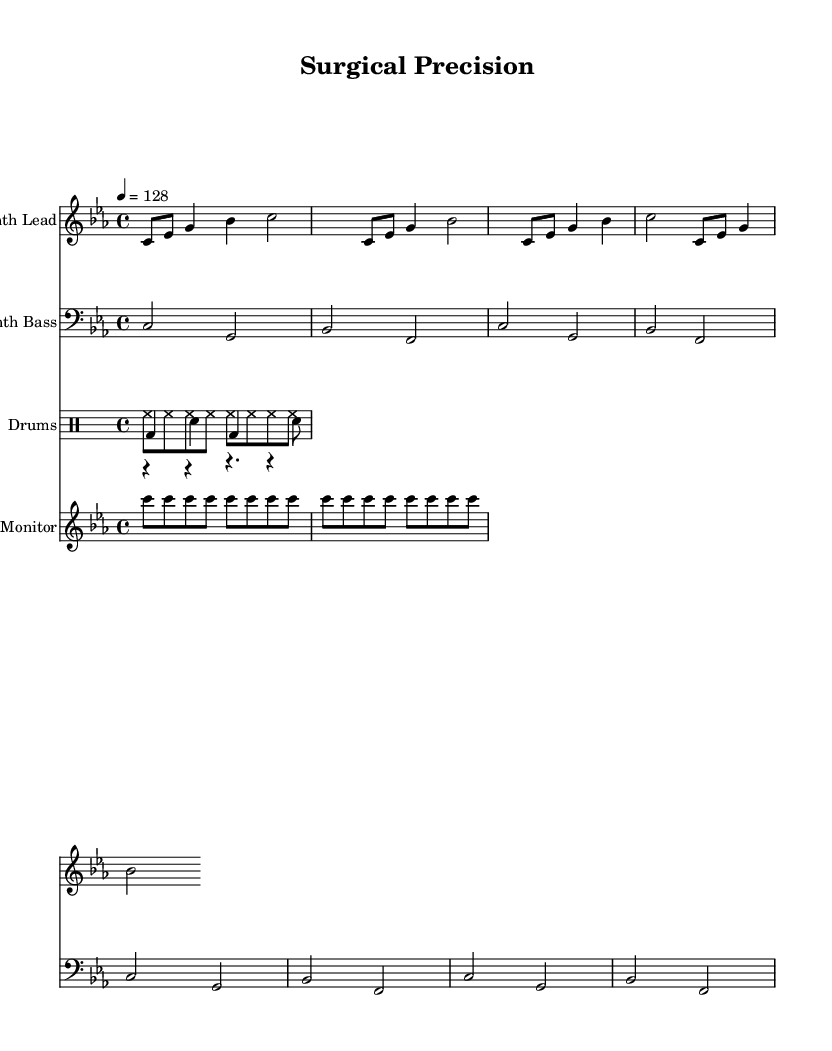What is the key signature of this music? The key signature is C minor, which indicates that it has three flats (B-flat, E-flat, and A-flat). This is determined by checking the key signature at the beginning of the staff where the notes are written.
Answer: C minor What is the time signature of this music? The time signature is 4/4, which means there are four beats in a measure and the quarter note gets one beat. This is indicated explicitly at the start of the score after the key signature.
Answer: 4/4 What is the tempo marking of this music? The tempo marking is 128 beats per minute, which sets the speed of the piece. This is specified as "4 = 128" at the start of the score, indicating that the quarter note is equal to 128 beats per minute.
Answer: 128 How many repetitions does the synth bass pattern have? The synth bass pattern is repeated four times, as indicated by the "repeat unfold 4" notation in the code. This means that the entire bass pattern is played four times in sequence.
Answer: 4 Which instrument plays the heart monitor pattern? The heart monitor pattern is played by a dedicated staff labeled "Heart Monitor" in the score. This indicates that this particular pattern is associated with a specific instrumental voice in the arrangement.
Answer: Heart Monitor How is the drum pattern structured in terms of beats? The drum patterns consist of kick, snare, and hi-hat each with specific rhythmic figures. The kick drum plays on beats 1 and 3 (bd4), the snare drum plays on the off-beats (sn), and the hi-hat plays steady eighth notes throughout. This division into distinct rhythmic figures showcases the dance characteristics of the composition.
Answer: Kick, Snare, Hi-Hat What rhythmic value is represented most frequently in the heart monitor staff? The rhythm in the heart monitor staff consists mainly of eighth notes, specifically one note per eighth note time unit repeated continuously. This continuous pulse mirrors the steady rhythm found in a heart monitor, reflecting the surgical theme.
Answer: Eighth notes 